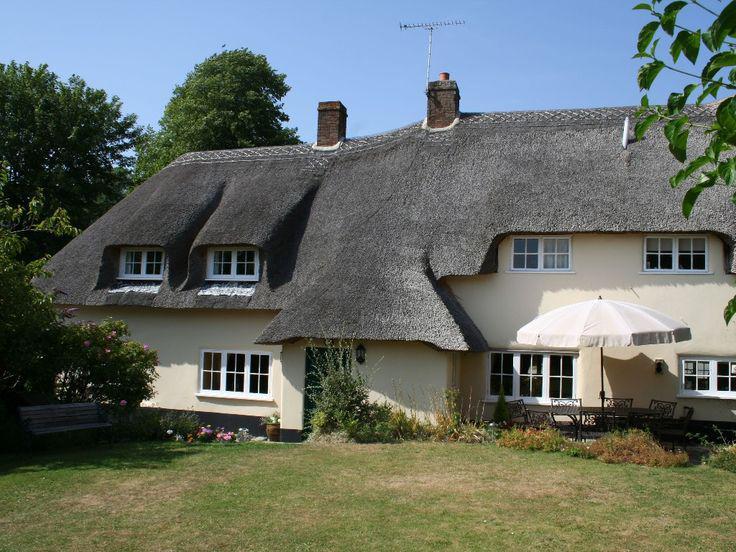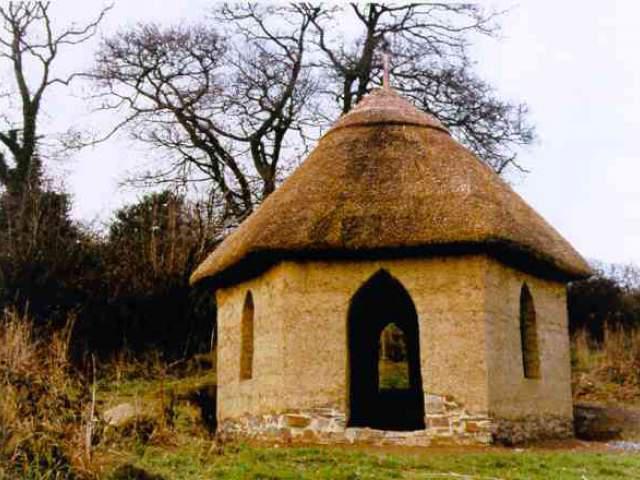The first image is the image on the left, the second image is the image on the right. Evaluate the accuracy of this statement regarding the images: "A building with a shaggy thatched roof topped with a notched border has two projecting dormer windows and stone columns at the entrance to the property.". Is it true? Answer yes or no. No. The first image is the image on the left, the second image is the image on the right. Evaluate the accuracy of this statement regarding the images: "A fence runs around the house in the image on the right.". Is it true? Answer yes or no. No. 